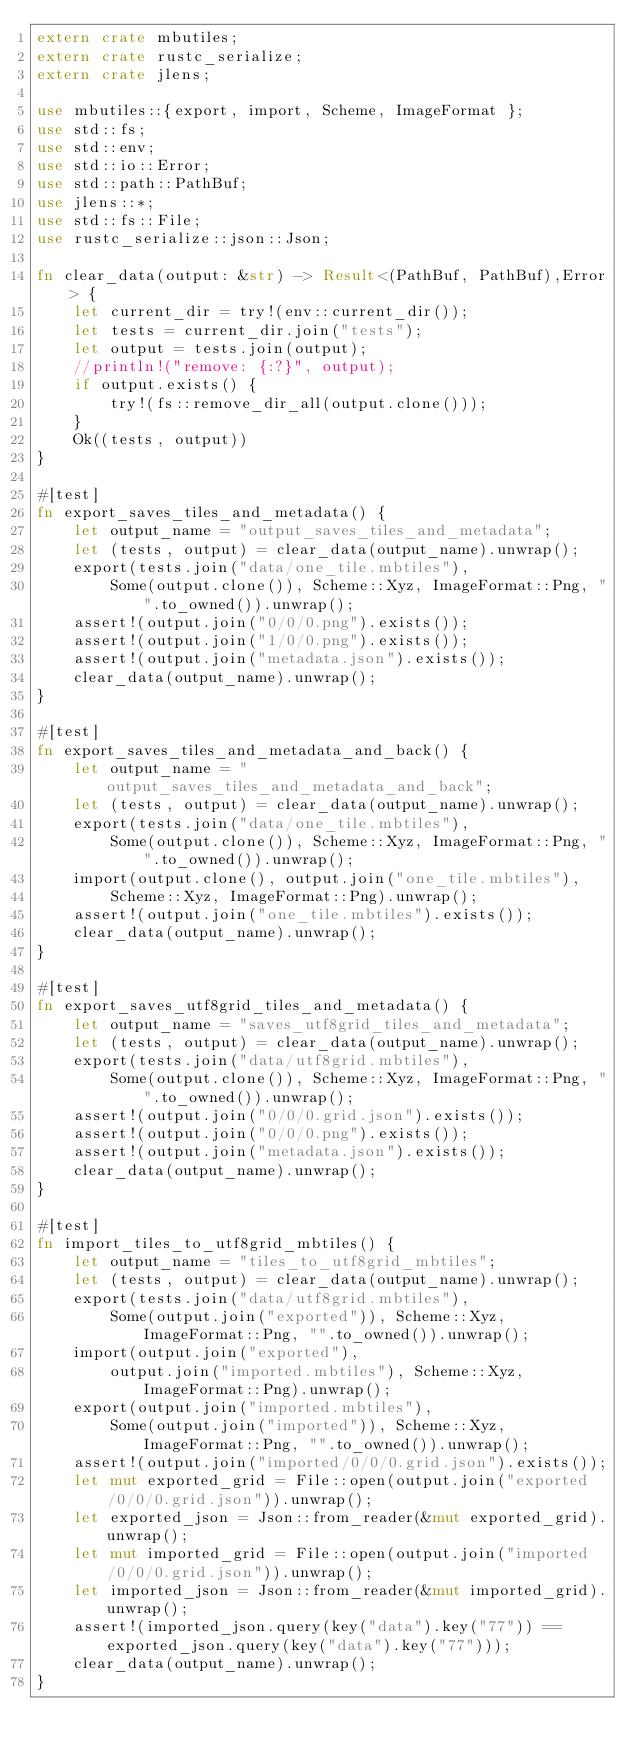Convert code to text. <code><loc_0><loc_0><loc_500><loc_500><_Rust_>extern crate mbutiles;
extern crate rustc_serialize;
extern crate jlens;

use mbutiles::{export, import, Scheme, ImageFormat };
use std::fs;
use std::env;
use std::io::Error;
use std::path::PathBuf;
use jlens::*;
use std::fs::File;
use rustc_serialize::json::Json;

fn clear_data(output: &str) -> Result<(PathBuf, PathBuf),Error> {
    let current_dir = try!(env::current_dir());
    let tests = current_dir.join("tests");
    let output = tests.join(output);
    //println!("remove: {:?}", output);
    if output.exists() {
        try!(fs::remove_dir_all(output.clone()));
    }
    Ok((tests, output))
}

#[test]
fn export_saves_tiles_and_metadata() {
    let output_name = "output_saves_tiles_and_metadata";
    let (tests, output) = clear_data(output_name).unwrap();
    export(tests.join("data/one_tile.mbtiles"),
        Some(output.clone()), Scheme::Xyz, ImageFormat::Png, "".to_owned()).unwrap();
    assert!(output.join("0/0/0.png").exists());
    assert!(output.join("1/0/0.png").exists());
    assert!(output.join("metadata.json").exists());
    clear_data(output_name).unwrap();
}

#[test]
fn export_saves_tiles_and_metadata_and_back() {
    let output_name = "output_saves_tiles_and_metadata_and_back";
    let (tests, output) = clear_data(output_name).unwrap();
    export(tests.join("data/one_tile.mbtiles"),
        Some(output.clone()), Scheme::Xyz, ImageFormat::Png, "".to_owned()).unwrap();
    import(output.clone(), output.join("one_tile.mbtiles"),
        Scheme::Xyz, ImageFormat::Png).unwrap();
    assert!(output.join("one_tile.mbtiles").exists());
    clear_data(output_name).unwrap();
}

#[test]
fn export_saves_utf8grid_tiles_and_metadata() {
    let output_name = "saves_utf8grid_tiles_and_metadata";
    let (tests, output) = clear_data(output_name).unwrap();
    export(tests.join("data/utf8grid.mbtiles"),
        Some(output.clone()), Scheme::Xyz, ImageFormat::Png, "".to_owned()).unwrap();
    assert!(output.join("0/0/0.grid.json").exists());
    assert!(output.join("0/0/0.png").exists());
    assert!(output.join("metadata.json").exists());
    clear_data(output_name).unwrap();
}

#[test]
fn import_tiles_to_utf8grid_mbtiles() {
    let output_name = "tiles_to_utf8grid_mbtiles";
    let (tests, output) = clear_data(output_name).unwrap();
    export(tests.join("data/utf8grid.mbtiles"),
        Some(output.join("exported")), Scheme::Xyz, ImageFormat::Png, "".to_owned()).unwrap();
    import(output.join("exported"),
        output.join("imported.mbtiles"), Scheme::Xyz, ImageFormat::Png).unwrap();
    export(output.join("imported.mbtiles"),
        Some(output.join("imported")), Scheme::Xyz, ImageFormat::Png, "".to_owned()).unwrap();
    assert!(output.join("imported/0/0/0.grid.json").exists());
    let mut exported_grid = File::open(output.join("exported/0/0/0.grid.json")).unwrap();
    let exported_json = Json::from_reader(&mut exported_grid).unwrap();
    let mut imported_grid = File::open(output.join("imported/0/0/0.grid.json")).unwrap();
    let imported_json = Json::from_reader(&mut imported_grid).unwrap();
    assert!(imported_json.query(key("data").key("77")) == exported_json.query(key("data").key("77")));
    clear_data(output_name).unwrap();
}
</code> 